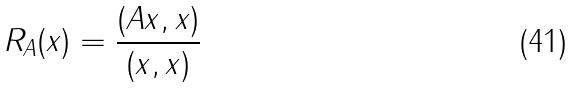<formula> <loc_0><loc_0><loc_500><loc_500>R _ { A } ( x ) = \frac { ( A x , x ) } { ( x , x ) }</formula> 